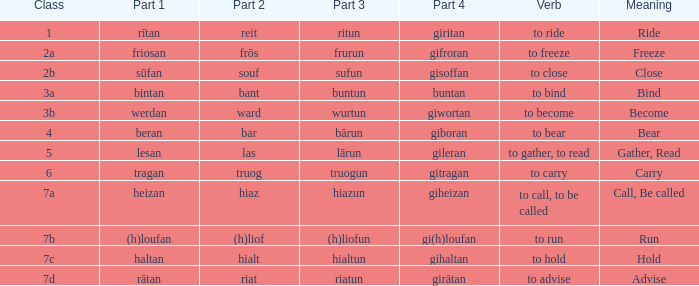What is the part 3 of the word in class 7a? Hiazun. 